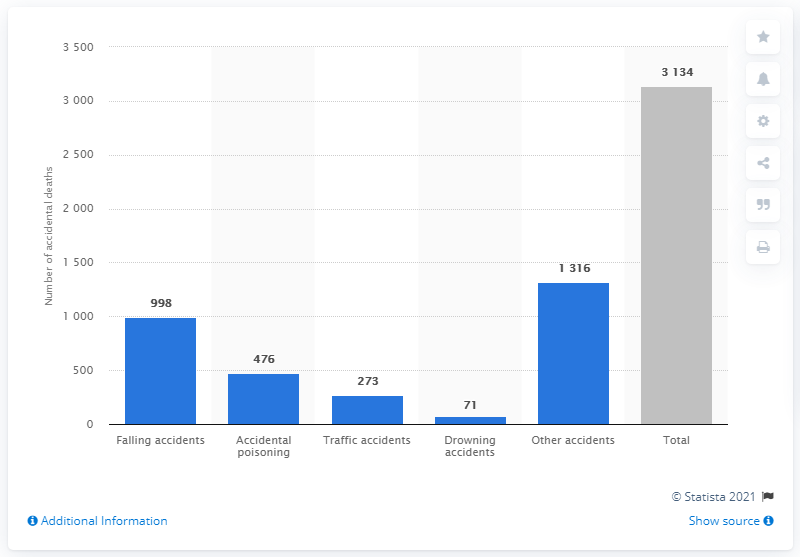Mention a couple of crucial points in this snapshot. In 2019, there were 476 deaths in Sweden due to accidental poisoning. 